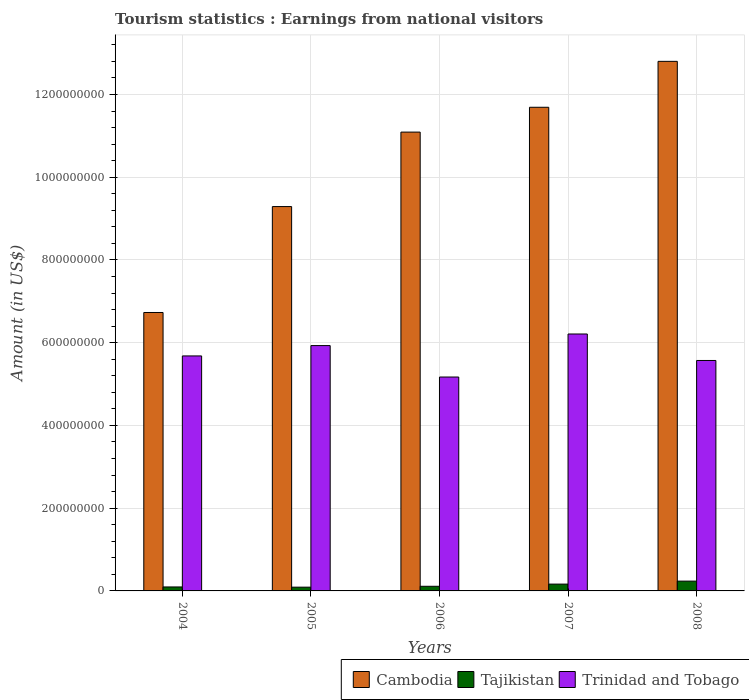How many groups of bars are there?
Provide a short and direct response. 5. Are the number of bars on each tick of the X-axis equal?
Provide a succinct answer. Yes. In how many cases, is the number of bars for a given year not equal to the number of legend labels?
Keep it short and to the point. 0. What is the earnings from national visitors in Cambodia in 2007?
Provide a short and direct response. 1.17e+09. Across all years, what is the maximum earnings from national visitors in Tajikistan?
Make the answer very short. 2.37e+07. Across all years, what is the minimum earnings from national visitors in Trinidad and Tobago?
Offer a terse response. 5.17e+08. In which year was the earnings from national visitors in Trinidad and Tobago maximum?
Provide a short and direct response. 2007. In which year was the earnings from national visitors in Cambodia minimum?
Provide a succinct answer. 2004. What is the total earnings from national visitors in Cambodia in the graph?
Your answer should be very brief. 5.16e+09. What is the difference between the earnings from national visitors in Cambodia in 2004 and that in 2005?
Provide a succinct answer. -2.56e+08. What is the difference between the earnings from national visitors in Tajikistan in 2008 and the earnings from national visitors in Cambodia in 2005?
Give a very brief answer. -9.05e+08. What is the average earnings from national visitors in Cambodia per year?
Offer a terse response. 1.03e+09. In the year 2008, what is the difference between the earnings from national visitors in Trinidad and Tobago and earnings from national visitors in Tajikistan?
Your answer should be compact. 5.33e+08. In how many years, is the earnings from national visitors in Tajikistan greater than 320000000 US$?
Provide a short and direct response. 0. What is the ratio of the earnings from national visitors in Tajikistan in 2005 to that in 2006?
Make the answer very short. 0.81. What is the difference between the highest and the second highest earnings from national visitors in Tajikistan?
Keep it short and to the point. 7.20e+06. What is the difference between the highest and the lowest earnings from national visitors in Cambodia?
Keep it short and to the point. 6.07e+08. In how many years, is the earnings from national visitors in Cambodia greater than the average earnings from national visitors in Cambodia taken over all years?
Offer a terse response. 3. What does the 2nd bar from the left in 2008 represents?
Give a very brief answer. Tajikistan. What does the 3rd bar from the right in 2005 represents?
Your response must be concise. Cambodia. Does the graph contain any zero values?
Give a very brief answer. No. Where does the legend appear in the graph?
Provide a succinct answer. Bottom right. How many legend labels are there?
Provide a short and direct response. 3. How are the legend labels stacked?
Make the answer very short. Horizontal. What is the title of the graph?
Keep it short and to the point. Tourism statistics : Earnings from national visitors. What is the label or title of the X-axis?
Your answer should be compact. Years. What is the Amount (in US$) of Cambodia in 2004?
Ensure brevity in your answer.  6.73e+08. What is the Amount (in US$) of Tajikistan in 2004?
Offer a very short reply. 9.60e+06. What is the Amount (in US$) of Trinidad and Tobago in 2004?
Provide a succinct answer. 5.68e+08. What is the Amount (in US$) of Cambodia in 2005?
Provide a short and direct response. 9.29e+08. What is the Amount (in US$) of Tajikistan in 2005?
Give a very brief answer. 9.10e+06. What is the Amount (in US$) of Trinidad and Tobago in 2005?
Keep it short and to the point. 5.93e+08. What is the Amount (in US$) in Cambodia in 2006?
Offer a very short reply. 1.11e+09. What is the Amount (in US$) of Tajikistan in 2006?
Ensure brevity in your answer.  1.12e+07. What is the Amount (in US$) of Trinidad and Tobago in 2006?
Your response must be concise. 5.17e+08. What is the Amount (in US$) in Cambodia in 2007?
Make the answer very short. 1.17e+09. What is the Amount (in US$) of Tajikistan in 2007?
Provide a succinct answer. 1.65e+07. What is the Amount (in US$) of Trinidad and Tobago in 2007?
Your answer should be very brief. 6.21e+08. What is the Amount (in US$) of Cambodia in 2008?
Make the answer very short. 1.28e+09. What is the Amount (in US$) of Tajikistan in 2008?
Your response must be concise. 2.37e+07. What is the Amount (in US$) of Trinidad and Tobago in 2008?
Your answer should be compact. 5.57e+08. Across all years, what is the maximum Amount (in US$) of Cambodia?
Keep it short and to the point. 1.28e+09. Across all years, what is the maximum Amount (in US$) in Tajikistan?
Make the answer very short. 2.37e+07. Across all years, what is the maximum Amount (in US$) of Trinidad and Tobago?
Your answer should be very brief. 6.21e+08. Across all years, what is the minimum Amount (in US$) in Cambodia?
Ensure brevity in your answer.  6.73e+08. Across all years, what is the minimum Amount (in US$) of Tajikistan?
Give a very brief answer. 9.10e+06. Across all years, what is the minimum Amount (in US$) of Trinidad and Tobago?
Provide a succinct answer. 5.17e+08. What is the total Amount (in US$) in Cambodia in the graph?
Give a very brief answer. 5.16e+09. What is the total Amount (in US$) in Tajikistan in the graph?
Your response must be concise. 7.01e+07. What is the total Amount (in US$) of Trinidad and Tobago in the graph?
Provide a short and direct response. 2.86e+09. What is the difference between the Amount (in US$) of Cambodia in 2004 and that in 2005?
Ensure brevity in your answer.  -2.56e+08. What is the difference between the Amount (in US$) of Tajikistan in 2004 and that in 2005?
Keep it short and to the point. 5.00e+05. What is the difference between the Amount (in US$) in Trinidad and Tobago in 2004 and that in 2005?
Your answer should be very brief. -2.50e+07. What is the difference between the Amount (in US$) of Cambodia in 2004 and that in 2006?
Ensure brevity in your answer.  -4.36e+08. What is the difference between the Amount (in US$) in Tajikistan in 2004 and that in 2006?
Give a very brief answer. -1.60e+06. What is the difference between the Amount (in US$) in Trinidad and Tobago in 2004 and that in 2006?
Make the answer very short. 5.10e+07. What is the difference between the Amount (in US$) of Cambodia in 2004 and that in 2007?
Offer a terse response. -4.96e+08. What is the difference between the Amount (in US$) in Tajikistan in 2004 and that in 2007?
Your response must be concise. -6.90e+06. What is the difference between the Amount (in US$) of Trinidad and Tobago in 2004 and that in 2007?
Offer a terse response. -5.30e+07. What is the difference between the Amount (in US$) of Cambodia in 2004 and that in 2008?
Provide a succinct answer. -6.07e+08. What is the difference between the Amount (in US$) in Tajikistan in 2004 and that in 2008?
Offer a very short reply. -1.41e+07. What is the difference between the Amount (in US$) of Trinidad and Tobago in 2004 and that in 2008?
Offer a very short reply. 1.10e+07. What is the difference between the Amount (in US$) of Cambodia in 2005 and that in 2006?
Your answer should be compact. -1.80e+08. What is the difference between the Amount (in US$) in Tajikistan in 2005 and that in 2006?
Your response must be concise. -2.10e+06. What is the difference between the Amount (in US$) in Trinidad and Tobago in 2005 and that in 2006?
Keep it short and to the point. 7.60e+07. What is the difference between the Amount (in US$) in Cambodia in 2005 and that in 2007?
Ensure brevity in your answer.  -2.40e+08. What is the difference between the Amount (in US$) of Tajikistan in 2005 and that in 2007?
Give a very brief answer. -7.40e+06. What is the difference between the Amount (in US$) of Trinidad and Tobago in 2005 and that in 2007?
Provide a succinct answer. -2.80e+07. What is the difference between the Amount (in US$) in Cambodia in 2005 and that in 2008?
Ensure brevity in your answer.  -3.51e+08. What is the difference between the Amount (in US$) in Tajikistan in 2005 and that in 2008?
Your response must be concise. -1.46e+07. What is the difference between the Amount (in US$) of Trinidad and Tobago in 2005 and that in 2008?
Give a very brief answer. 3.60e+07. What is the difference between the Amount (in US$) in Cambodia in 2006 and that in 2007?
Keep it short and to the point. -6.00e+07. What is the difference between the Amount (in US$) of Tajikistan in 2006 and that in 2007?
Provide a short and direct response. -5.30e+06. What is the difference between the Amount (in US$) in Trinidad and Tobago in 2006 and that in 2007?
Keep it short and to the point. -1.04e+08. What is the difference between the Amount (in US$) of Cambodia in 2006 and that in 2008?
Provide a short and direct response. -1.71e+08. What is the difference between the Amount (in US$) of Tajikistan in 2006 and that in 2008?
Make the answer very short. -1.25e+07. What is the difference between the Amount (in US$) in Trinidad and Tobago in 2006 and that in 2008?
Give a very brief answer. -4.00e+07. What is the difference between the Amount (in US$) in Cambodia in 2007 and that in 2008?
Keep it short and to the point. -1.11e+08. What is the difference between the Amount (in US$) in Tajikistan in 2007 and that in 2008?
Your response must be concise. -7.20e+06. What is the difference between the Amount (in US$) of Trinidad and Tobago in 2007 and that in 2008?
Your answer should be very brief. 6.40e+07. What is the difference between the Amount (in US$) in Cambodia in 2004 and the Amount (in US$) in Tajikistan in 2005?
Your answer should be compact. 6.64e+08. What is the difference between the Amount (in US$) of Cambodia in 2004 and the Amount (in US$) of Trinidad and Tobago in 2005?
Offer a terse response. 8.00e+07. What is the difference between the Amount (in US$) in Tajikistan in 2004 and the Amount (in US$) in Trinidad and Tobago in 2005?
Ensure brevity in your answer.  -5.83e+08. What is the difference between the Amount (in US$) of Cambodia in 2004 and the Amount (in US$) of Tajikistan in 2006?
Give a very brief answer. 6.62e+08. What is the difference between the Amount (in US$) of Cambodia in 2004 and the Amount (in US$) of Trinidad and Tobago in 2006?
Provide a succinct answer. 1.56e+08. What is the difference between the Amount (in US$) of Tajikistan in 2004 and the Amount (in US$) of Trinidad and Tobago in 2006?
Your answer should be very brief. -5.07e+08. What is the difference between the Amount (in US$) of Cambodia in 2004 and the Amount (in US$) of Tajikistan in 2007?
Offer a terse response. 6.56e+08. What is the difference between the Amount (in US$) in Cambodia in 2004 and the Amount (in US$) in Trinidad and Tobago in 2007?
Offer a terse response. 5.20e+07. What is the difference between the Amount (in US$) in Tajikistan in 2004 and the Amount (in US$) in Trinidad and Tobago in 2007?
Your response must be concise. -6.11e+08. What is the difference between the Amount (in US$) of Cambodia in 2004 and the Amount (in US$) of Tajikistan in 2008?
Give a very brief answer. 6.49e+08. What is the difference between the Amount (in US$) in Cambodia in 2004 and the Amount (in US$) in Trinidad and Tobago in 2008?
Provide a succinct answer. 1.16e+08. What is the difference between the Amount (in US$) in Tajikistan in 2004 and the Amount (in US$) in Trinidad and Tobago in 2008?
Provide a short and direct response. -5.47e+08. What is the difference between the Amount (in US$) in Cambodia in 2005 and the Amount (in US$) in Tajikistan in 2006?
Keep it short and to the point. 9.18e+08. What is the difference between the Amount (in US$) in Cambodia in 2005 and the Amount (in US$) in Trinidad and Tobago in 2006?
Ensure brevity in your answer.  4.12e+08. What is the difference between the Amount (in US$) in Tajikistan in 2005 and the Amount (in US$) in Trinidad and Tobago in 2006?
Provide a succinct answer. -5.08e+08. What is the difference between the Amount (in US$) of Cambodia in 2005 and the Amount (in US$) of Tajikistan in 2007?
Offer a very short reply. 9.12e+08. What is the difference between the Amount (in US$) in Cambodia in 2005 and the Amount (in US$) in Trinidad and Tobago in 2007?
Your response must be concise. 3.08e+08. What is the difference between the Amount (in US$) in Tajikistan in 2005 and the Amount (in US$) in Trinidad and Tobago in 2007?
Your answer should be very brief. -6.12e+08. What is the difference between the Amount (in US$) in Cambodia in 2005 and the Amount (in US$) in Tajikistan in 2008?
Provide a succinct answer. 9.05e+08. What is the difference between the Amount (in US$) of Cambodia in 2005 and the Amount (in US$) of Trinidad and Tobago in 2008?
Offer a very short reply. 3.72e+08. What is the difference between the Amount (in US$) of Tajikistan in 2005 and the Amount (in US$) of Trinidad and Tobago in 2008?
Provide a short and direct response. -5.48e+08. What is the difference between the Amount (in US$) in Cambodia in 2006 and the Amount (in US$) in Tajikistan in 2007?
Provide a succinct answer. 1.09e+09. What is the difference between the Amount (in US$) of Cambodia in 2006 and the Amount (in US$) of Trinidad and Tobago in 2007?
Your answer should be compact. 4.88e+08. What is the difference between the Amount (in US$) in Tajikistan in 2006 and the Amount (in US$) in Trinidad and Tobago in 2007?
Your answer should be very brief. -6.10e+08. What is the difference between the Amount (in US$) of Cambodia in 2006 and the Amount (in US$) of Tajikistan in 2008?
Your answer should be compact. 1.09e+09. What is the difference between the Amount (in US$) of Cambodia in 2006 and the Amount (in US$) of Trinidad and Tobago in 2008?
Offer a terse response. 5.52e+08. What is the difference between the Amount (in US$) in Tajikistan in 2006 and the Amount (in US$) in Trinidad and Tobago in 2008?
Your answer should be very brief. -5.46e+08. What is the difference between the Amount (in US$) of Cambodia in 2007 and the Amount (in US$) of Tajikistan in 2008?
Offer a very short reply. 1.15e+09. What is the difference between the Amount (in US$) of Cambodia in 2007 and the Amount (in US$) of Trinidad and Tobago in 2008?
Make the answer very short. 6.12e+08. What is the difference between the Amount (in US$) of Tajikistan in 2007 and the Amount (in US$) of Trinidad and Tobago in 2008?
Provide a succinct answer. -5.40e+08. What is the average Amount (in US$) of Cambodia per year?
Offer a terse response. 1.03e+09. What is the average Amount (in US$) of Tajikistan per year?
Make the answer very short. 1.40e+07. What is the average Amount (in US$) in Trinidad and Tobago per year?
Provide a succinct answer. 5.71e+08. In the year 2004, what is the difference between the Amount (in US$) of Cambodia and Amount (in US$) of Tajikistan?
Offer a terse response. 6.63e+08. In the year 2004, what is the difference between the Amount (in US$) in Cambodia and Amount (in US$) in Trinidad and Tobago?
Offer a very short reply. 1.05e+08. In the year 2004, what is the difference between the Amount (in US$) in Tajikistan and Amount (in US$) in Trinidad and Tobago?
Give a very brief answer. -5.58e+08. In the year 2005, what is the difference between the Amount (in US$) in Cambodia and Amount (in US$) in Tajikistan?
Keep it short and to the point. 9.20e+08. In the year 2005, what is the difference between the Amount (in US$) in Cambodia and Amount (in US$) in Trinidad and Tobago?
Your answer should be very brief. 3.36e+08. In the year 2005, what is the difference between the Amount (in US$) in Tajikistan and Amount (in US$) in Trinidad and Tobago?
Your answer should be very brief. -5.84e+08. In the year 2006, what is the difference between the Amount (in US$) of Cambodia and Amount (in US$) of Tajikistan?
Keep it short and to the point. 1.10e+09. In the year 2006, what is the difference between the Amount (in US$) of Cambodia and Amount (in US$) of Trinidad and Tobago?
Your answer should be very brief. 5.92e+08. In the year 2006, what is the difference between the Amount (in US$) in Tajikistan and Amount (in US$) in Trinidad and Tobago?
Give a very brief answer. -5.06e+08. In the year 2007, what is the difference between the Amount (in US$) in Cambodia and Amount (in US$) in Tajikistan?
Your answer should be very brief. 1.15e+09. In the year 2007, what is the difference between the Amount (in US$) in Cambodia and Amount (in US$) in Trinidad and Tobago?
Ensure brevity in your answer.  5.48e+08. In the year 2007, what is the difference between the Amount (in US$) of Tajikistan and Amount (in US$) of Trinidad and Tobago?
Offer a terse response. -6.04e+08. In the year 2008, what is the difference between the Amount (in US$) in Cambodia and Amount (in US$) in Tajikistan?
Provide a short and direct response. 1.26e+09. In the year 2008, what is the difference between the Amount (in US$) in Cambodia and Amount (in US$) in Trinidad and Tobago?
Provide a short and direct response. 7.23e+08. In the year 2008, what is the difference between the Amount (in US$) of Tajikistan and Amount (in US$) of Trinidad and Tobago?
Offer a terse response. -5.33e+08. What is the ratio of the Amount (in US$) in Cambodia in 2004 to that in 2005?
Your answer should be compact. 0.72. What is the ratio of the Amount (in US$) of Tajikistan in 2004 to that in 2005?
Your response must be concise. 1.05. What is the ratio of the Amount (in US$) of Trinidad and Tobago in 2004 to that in 2005?
Offer a terse response. 0.96. What is the ratio of the Amount (in US$) in Cambodia in 2004 to that in 2006?
Offer a terse response. 0.61. What is the ratio of the Amount (in US$) of Trinidad and Tobago in 2004 to that in 2006?
Offer a terse response. 1.1. What is the ratio of the Amount (in US$) of Cambodia in 2004 to that in 2007?
Your response must be concise. 0.58. What is the ratio of the Amount (in US$) in Tajikistan in 2004 to that in 2007?
Keep it short and to the point. 0.58. What is the ratio of the Amount (in US$) of Trinidad and Tobago in 2004 to that in 2007?
Provide a short and direct response. 0.91. What is the ratio of the Amount (in US$) of Cambodia in 2004 to that in 2008?
Keep it short and to the point. 0.53. What is the ratio of the Amount (in US$) in Tajikistan in 2004 to that in 2008?
Provide a succinct answer. 0.41. What is the ratio of the Amount (in US$) in Trinidad and Tobago in 2004 to that in 2008?
Give a very brief answer. 1.02. What is the ratio of the Amount (in US$) in Cambodia in 2005 to that in 2006?
Provide a short and direct response. 0.84. What is the ratio of the Amount (in US$) of Tajikistan in 2005 to that in 2006?
Your response must be concise. 0.81. What is the ratio of the Amount (in US$) of Trinidad and Tobago in 2005 to that in 2006?
Provide a short and direct response. 1.15. What is the ratio of the Amount (in US$) of Cambodia in 2005 to that in 2007?
Give a very brief answer. 0.79. What is the ratio of the Amount (in US$) of Tajikistan in 2005 to that in 2007?
Make the answer very short. 0.55. What is the ratio of the Amount (in US$) in Trinidad and Tobago in 2005 to that in 2007?
Your response must be concise. 0.95. What is the ratio of the Amount (in US$) of Cambodia in 2005 to that in 2008?
Your response must be concise. 0.73. What is the ratio of the Amount (in US$) of Tajikistan in 2005 to that in 2008?
Make the answer very short. 0.38. What is the ratio of the Amount (in US$) of Trinidad and Tobago in 2005 to that in 2008?
Give a very brief answer. 1.06. What is the ratio of the Amount (in US$) in Cambodia in 2006 to that in 2007?
Offer a terse response. 0.95. What is the ratio of the Amount (in US$) of Tajikistan in 2006 to that in 2007?
Your answer should be compact. 0.68. What is the ratio of the Amount (in US$) of Trinidad and Tobago in 2006 to that in 2007?
Your answer should be compact. 0.83. What is the ratio of the Amount (in US$) of Cambodia in 2006 to that in 2008?
Provide a short and direct response. 0.87. What is the ratio of the Amount (in US$) in Tajikistan in 2006 to that in 2008?
Provide a short and direct response. 0.47. What is the ratio of the Amount (in US$) in Trinidad and Tobago in 2006 to that in 2008?
Provide a succinct answer. 0.93. What is the ratio of the Amount (in US$) of Cambodia in 2007 to that in 2008?
Your answer should be very brief. 0.91. What is the ratio of the Amount (in US$) of Tajikistan in 2007 to that in 2008?
Make the answer very short. 0.7. What is the ratio of the Amount (in US$) in Trinidad and Tobago in 2007 to that in 2008?
Make the answer very short. 1.11. What is the difference between the highest and the second highest Amount (in US$) in Cambodia?
Your answer should be very brief. 1.11e+08. What is the difference between the highest and the second highest Amount (in US$) of Tajikistan?
Ensure brevity in your answer.  7.20e+06. What is the difference between the highest and the second highest Amount (in US$) of Trinidad and Tobago?
Offer a terse response. 2.80e+07. What is the difference between the highest and the lowest Amount (in US$) of Cambodia?
Your answer should be compact. 6.07e+08. What is the difference between the highest and the lowest Amount (in US$) in Tajikistan?
Offer a terse response. 1.46e+07. What is the difference between the highest and the lowest Amount (in US$) in Trinidad and Tobago?
Provide a succinct answer. 1.04e+08. 